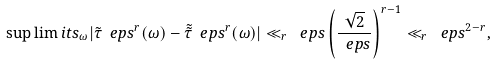<formula> <loc_0><loc_0><loc_500><loc_500>\sup \lim i t s _ { \omega } | \tilde { \tau } _ { \ } e p s ^ { r } ( \omega ) - \tilde { \tilde { \tau } } _ { \ } e p s ^ { r } ( \omega ) | \ll _ { r } \ e p s \left ( \frac { \sqrt { 2 } } { \ e p s } \right ) ^ { r - 1 } \ll _ { r } \ e p s ^ { 2 - r } ,</formula> 